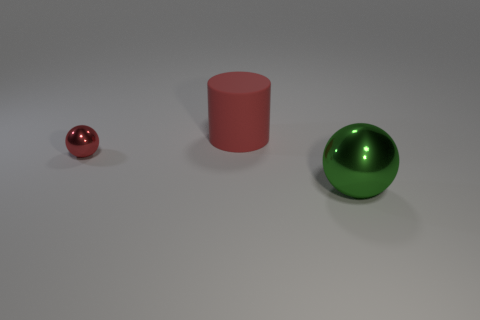There is another object that is the same size as the rubber thing; what shape is it? sphere 